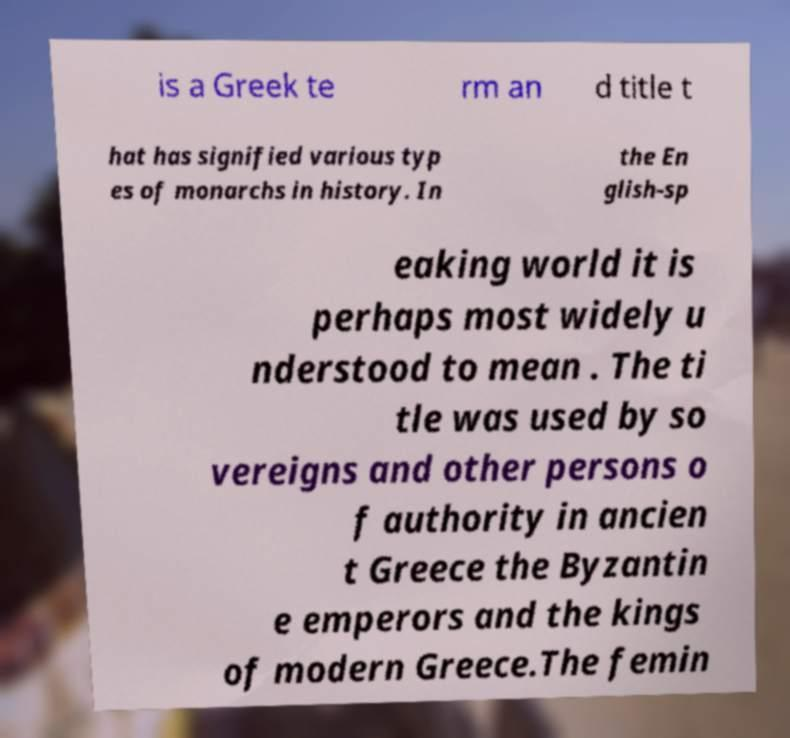Please read and relay the text visible in this image. What does it say? is a Greek te rm an d title t hat has signified various typ es of monarchs in history. In the En glish-sp eaking world it is perhaps most widely u nderstood to mean . The ti tle was used by so vereigns and other persons o f authority in ancien t Greece the Byzantin e emperors and the kings of modern Greece.The femin 